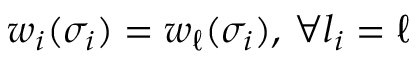Convert formula to latex. <formula><loc_0><loc_0><loc_500><loc_500>w _ { i } ( \sigma _ { i } ) = w _ { \ell } ( \sigma _ { i } ) , \, \forall l _ { i } = \ell</formula> 